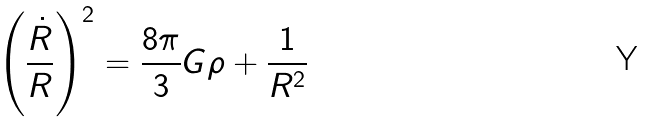<formula> <loc_0><loc_0><loc_500><loc_500>\left ( \frac { \dot { R } } { R } \right ) ^ { 2 } = \frac { 8 \pi } { 3 } G \rho + \frac { 1 } { R ^ { 2 } }</formula> 